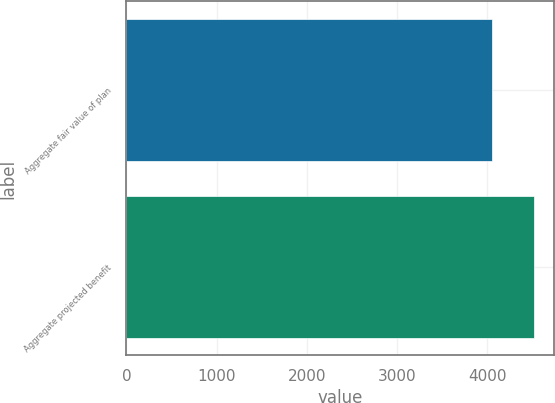<chart> <loc_0><loc_0><loc_500><loc_500><bar_chart><fcel>Aggregate fair value of plan<fcel>Aggregate projected benefit<nl><fcel>4051<fcel>4512<nl></chart> 